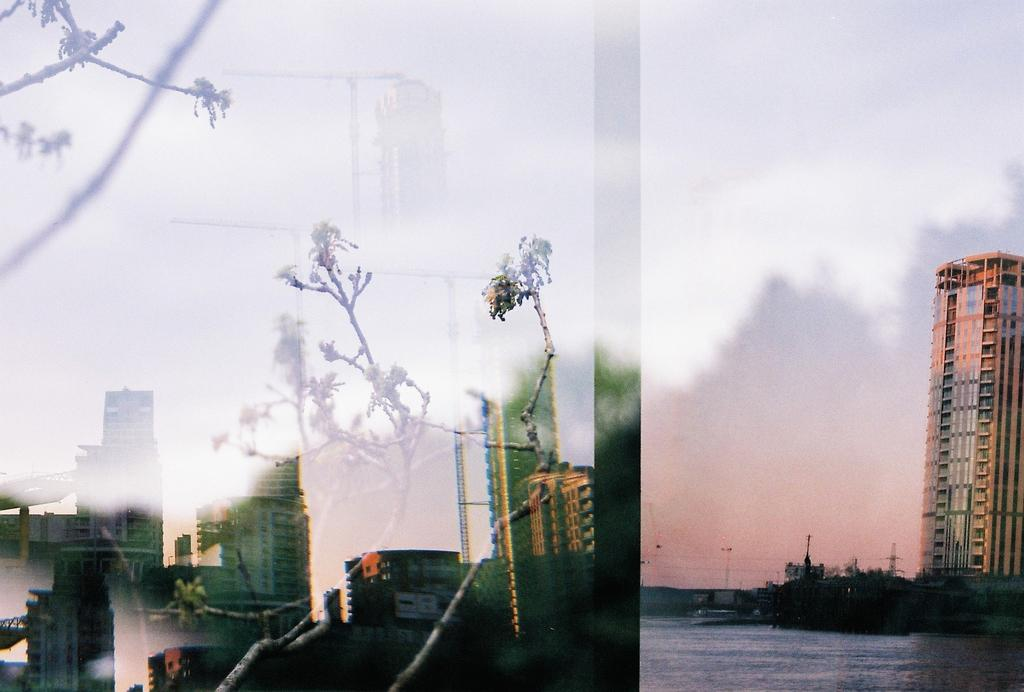What type of structures can be seen in the image? There are buildings in the image. What other natural elements are present in the image? There are trees in the image. What can be seen above the buildings and trees? The sky is visible in the image. What objects are supporting wires or signs in the image? There are poles in the image. What type of horse can be seen singing a song in the image? There is no horse or singing in the image; it features buildings, trees, the sky, and poles. 